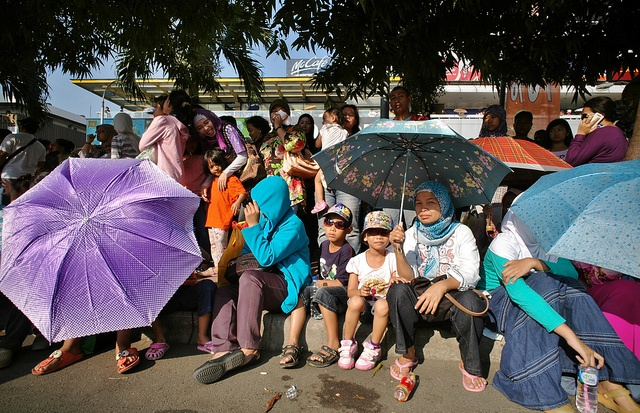Describe the objects in this image and their specific colors. I can see people in black, maroon, and gray tones, umbrella in black, violet, and purple tones, people in black, gray, and blue tones, umbrella in black, gray, purple, and lightgray tones, and people in black, white, gray, and tan tones in this image. 